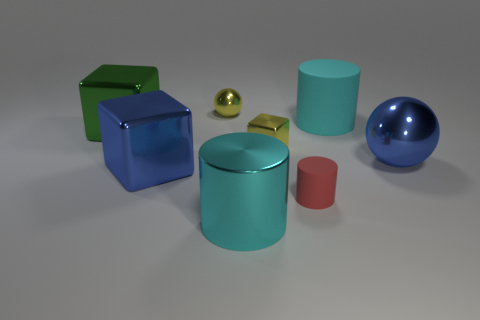What number of tiny things are yellow metallic spheres or cyan cylinders?
Your response must be concise. 1. There is a large green thing that is made of the same material as the blue block; what shape is it?
Provide a succinct answer. Cube. Is the number of shiny cylinders in front of the yellow metal block less than the number of gray objects?
Ensure brevity in your answer.  No. Does the big green shiny object have the same shape as the cyan matte object?
Your response must be concise. No. What number of shiny objects are large cyan objects or small gray objects?
Your answer should be compact. 1. Is there a yellow cube that has the same size as the green metal block?
Provide a succinct answer. No. There is a thing that is the same color as the large shiny cylinder; what is its shape?
Ensure brevity in your answer.  Cylinder. What number of yellow balls have the same size as the blue metal ball?
Provide a short and direct response. 0. There is a cube that is left of the big blue shiny cube; does it have the same size as the cylinder behind the blue ball?
Keep it short and to the point. Yes. How many objects are either tiny yellow metallic blocks or big matte objects that are to the right of the big green thing?
Offer a terse response. 2. 